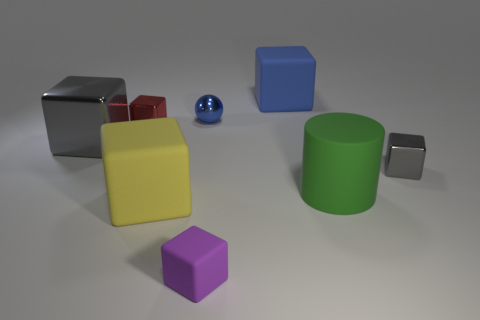What material is the big gray object?
Your answer should be very brief. Metal. What shape is the big gray thing?
Your answer should be very brief. Cube. What number of blocks are the same color as the big metallic object?
Provide a succinct answer. 1. What material is the gray object that is in front of the gray block left of the matte block behind the big green cylinder?
Offer a terse response. Metal. What number of gray objects are tiny things or big rubber cubes?
Offer a terse response. 1. There is a purple object in front of the small metal thing that is on the right side of the big matte object that is behind the tiny metal ball; what size is it?
Your answer should be compact. Small. What size is the yellow rubber object that is the same shape as the small purple matte thing?
Ensure brevity in your answer.  Large. What number of tiny things are green things or gray blocks?
Ensure brevity in your answer.  1. Is the blue thing that is right of the small blue ball made of the same material as the gray block left of the blue matte thing?
Ensure brevity in your answer.  No. There is a cube that is behind the red metallic cube; what material is it?
Ensure brevity in your answer.  Rubber. 